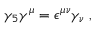<formula> <loc_0><loc_0><loc_500><loc_500>\gamma _ { 5 } \gamma ^ { \mu } = \epsilon ^ { \mu \nu } \gamma _ { \nu } \, ,</formula> 